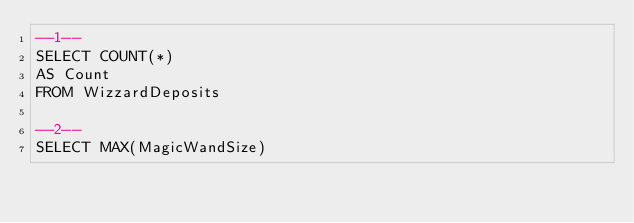<code> <loc_0><loc_0><loc_500><loc_500><_SQL_>--1--
SELECT COUNT(*)
AS Count
FROM WizzardDeposits

--2--
SELECT MAX(MagicWandSize) </code> 